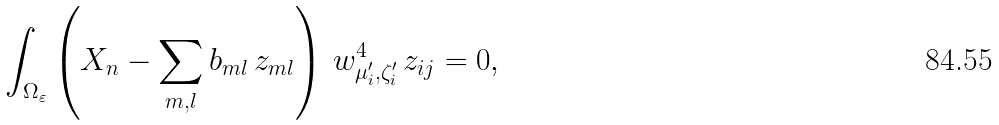<formula> <loc_0><loc_0><loc_500><loc_500>\int _ { \Omega _ { \varepsilon } } \left ( X _ { n } - \sum _ { m , l } b _ { m l } \, { z } _ { m l } \right ) \, w _ { \mu _ { i } ^ { \prime } , \zeta _ { i } ^ { \prime } } ^ { 4 } \, z _ { i j } = 0 ,</formula> 